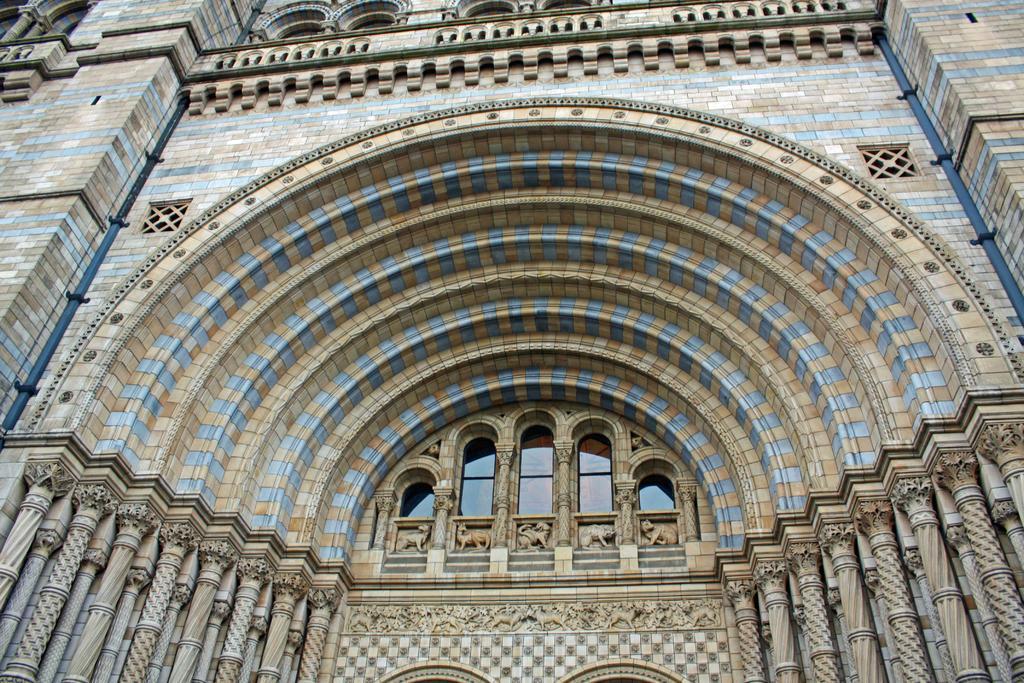Please provide a concise description of this image. This is the front view of a building with glass windows. 